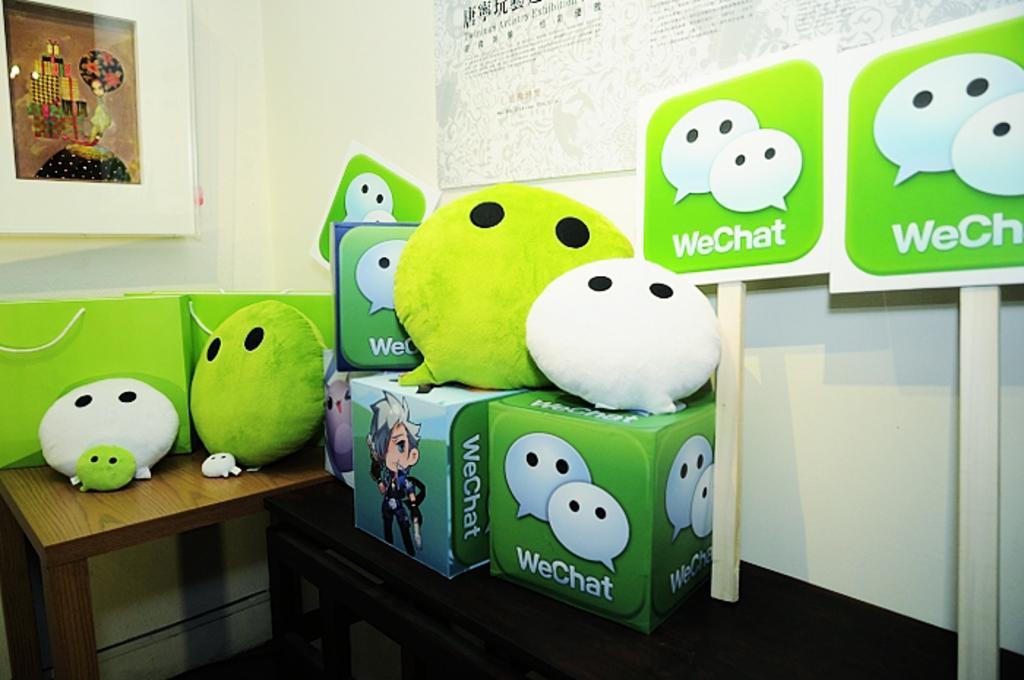How would you summarize this image in a sentence or two? In this image there are bag on the table. On the wall there is a frame. 